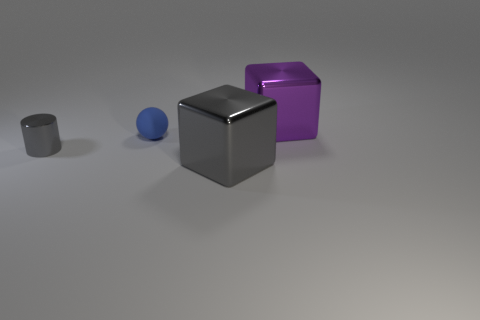Add 2 purple blocks. How many objects exist? 6 Subtract all cylinders. How many objects are left? 3 Subtract all cylinders. Subtract all cubes. How many objects are left? 1 Add 1 tiny gray things. How many tiny gray things are left? 2 Add 1 big gray metal blocks. How many big gray metal blocks exist? 2 Subtract 0 yellow cylinders. How many objects are left? 4 